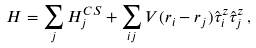Convert formula to latex. <formula><loc_0><loc_0><loc_500><loc_500>H = \sum _ { j } H _ { j } ^ { C S } + \sum _ { i j } V ( { r } _ { i } - { r } _ { j } ) \hat { \tau } _ { i } ^ { z } \hat { \tau } _ { j } ^ { z } \, ,</formula> 